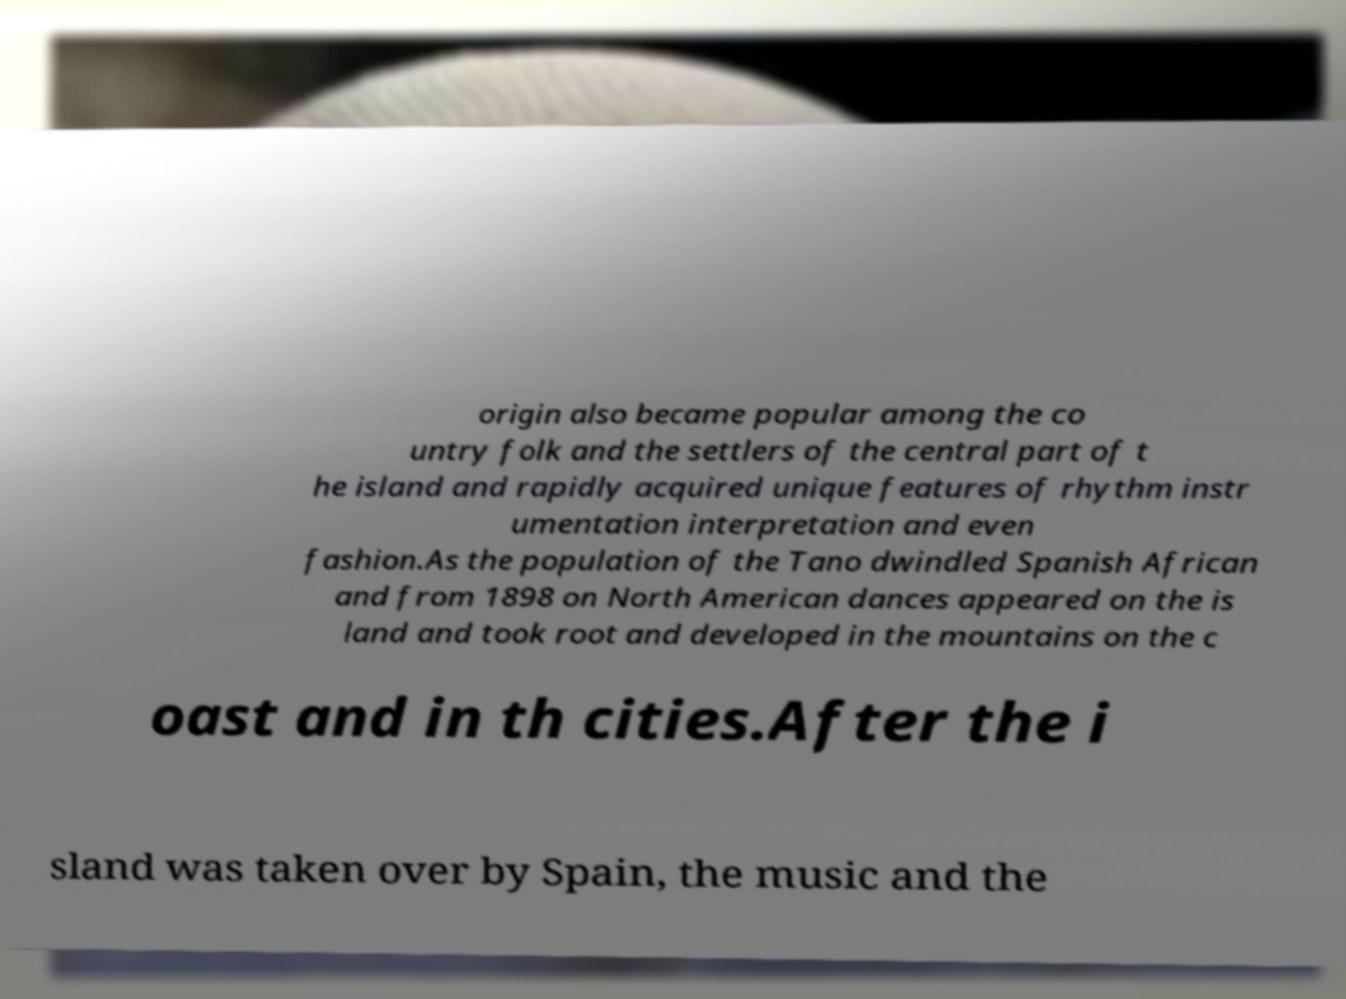Could you extract and type out the text from this image? origin also became popular among the co untry folk and the settlers of the central part of t he island and rapidly acquired unique features of rhythm instr umentation interpretation and even fashion.As the population of the Tano dwindled Spanish African and from 1898 on North American dances appeared on the is land and took root and developed in the mountains on the c oast and in th cities.After the i sland was taken over by Spain, the music and the 